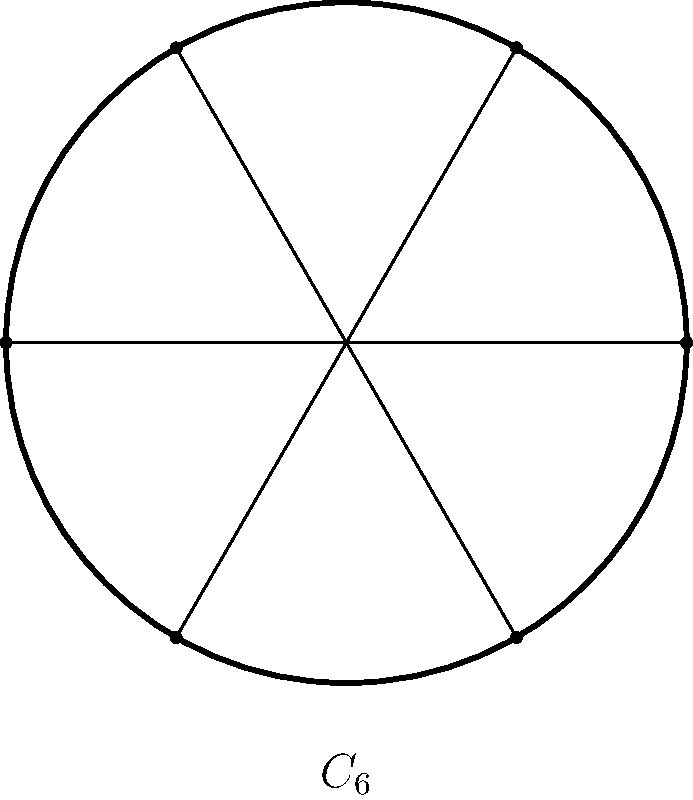A flywheel design for a new engine has a symmetrical arrangement of 6 equally spaced spokes. Using group theory, determine the order of the cyclic group that describes the rotational symmetry of this flywheel. How many unique rotations (including the identity) preserve the flywheel's appearance? To solve this problem, we need to consider the rotational symmetry of the flywheel:

1. The flywheel has 6 equally spaced spokes, which means it has 6-fold rotational symmetry.

2. In group theory, this symmetry is described by the cyclic group $C_6$.

3. The order of a cyclic group is equal to the number of elements in the group, which corresponds to the number of distinct rotations that preserve the object's appearance.

4. For $C_6$, we have the following rotations:
   - Identity rotation (0°)
   - Rotation by 60°
   - Rotation by 120°
   - Rotation by 180°
   - Rotation by 240°
   - Rotation by 300°

5. Each of these rotations brings the flywheel back to a state indistinguishable from its original position.

6. Therefore, there are 6 unique rotations (including the identity) that preserve the flywheel's appearance.

7. The order of the cyclic group $C_6$ is 6.
Answer: 6 